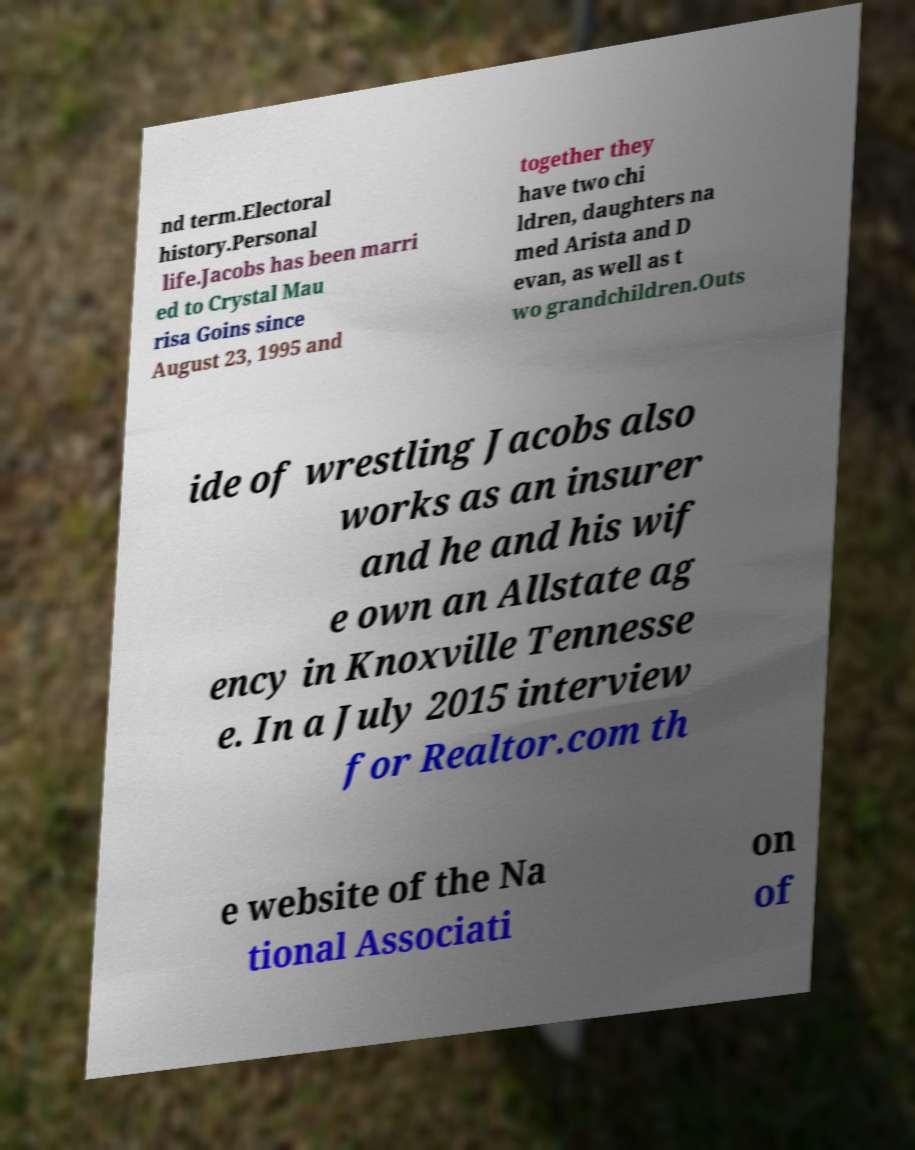Can you read and provide the text displayed in the image?This photo seems to have some interesting text. Can you extract and type it out for me? nd term.Electoral history.Personal life.Jacobs has been marri ed to Crystal Mau risa Goins since August 23, 1995 and together they have two chi ldren, daughters na med Arista and D evan, as well as t wo grandchildren.Outs ide of wrestling Jacobs also works as an insurer and he and his wif e own an Allstate ag ency in Knoxville Tennesse e. In a July 2015 interview for Realtor.com th e website of the Na tional Associati on of 